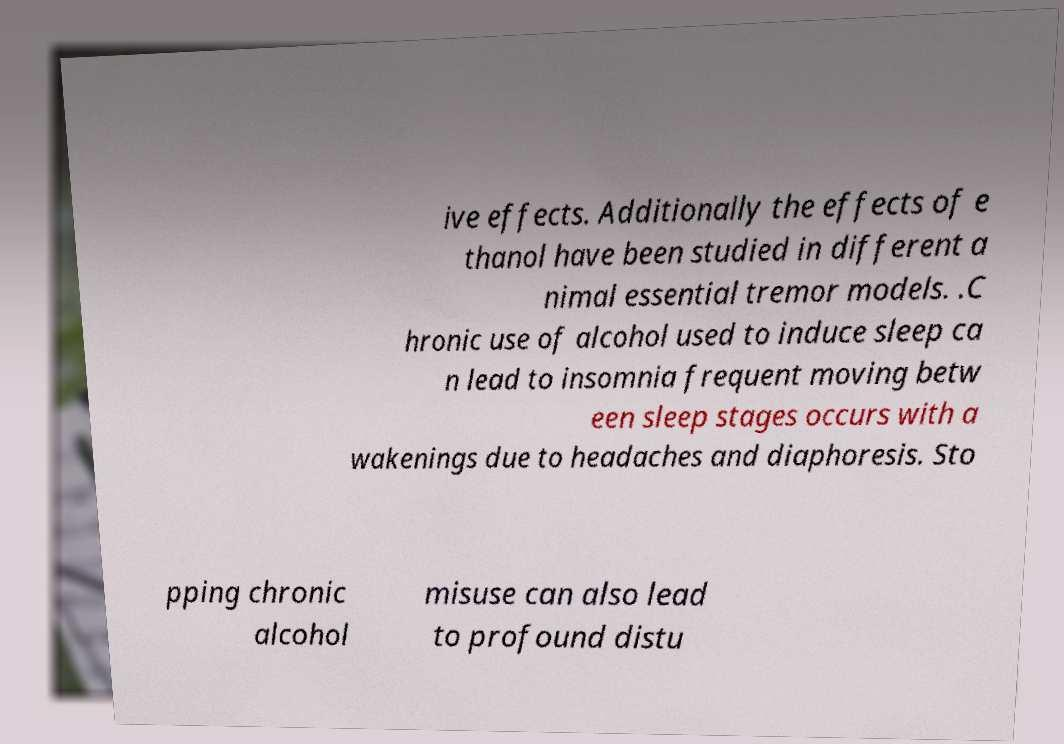Could you extract and type out the text from this image? ive effects. Additionally the effects of e thanol have been studied in different a nimal essential tremor models. .C hronic use of alcohol used to induce sleep ca n lead to insomnia frequent moving betw een sleep stages occurs with a wakenings due to headaches and diaphoresis. Sto pping chronic alcohol misuse can also lead to profound distu 